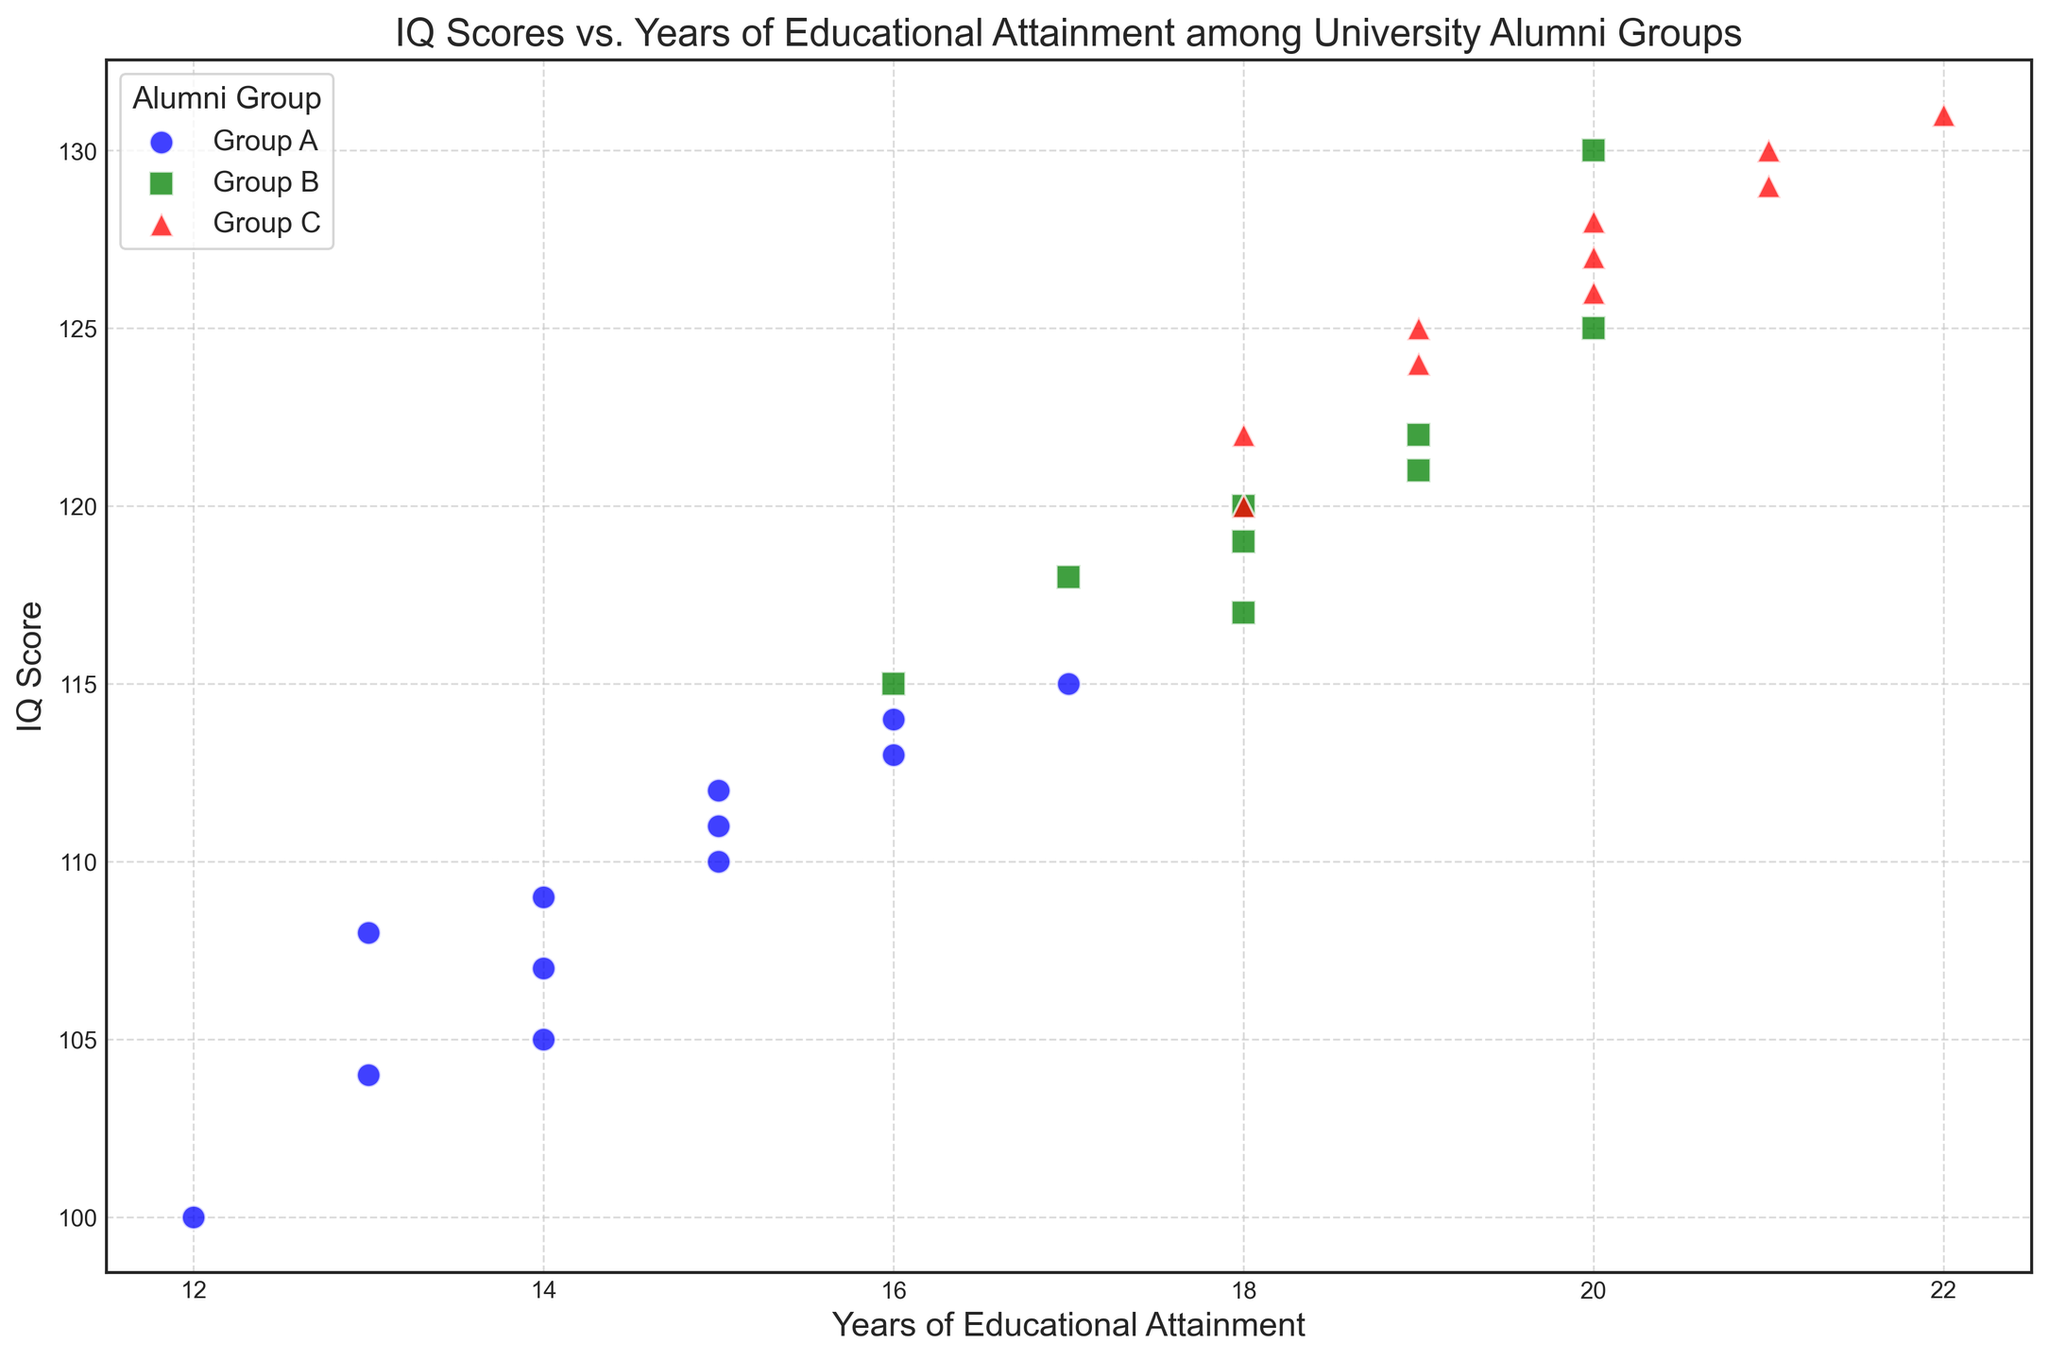What is the average IQ score for Group A alumni? To find the average IQ score for Group A alumni, sum the IQ scores for Group A and divide by the number of data points. The IQ scores for Group A are 110, 105, 100, 108, 112, 109, 104, 107, 111, 113, 114, and 115. The sum is 1208, and there are 12 data points. So, the average is 1208 / 12.
Answer: 100.67 Which alumni group has the highest IQ score in the dataset? For this question, we need to identify the alumni group associated with the highest IQ score in the scatter plot. The highest IQ score is 131, and it belongs to Group C.
Answer: Group C What is the range of years of educational attainment for Group B? To calculate the range, subtract the minimum years of educational attainment from the maximum years for Group B. Group B has educational years of 16, 20, 17, 18, 19, 18, 19, 19, and 20. The range is 20 - 16.
Answer: 4 Do alumni with higher years of educational attainment generally have higher IQ scores across all groups? To answer this, observe the scatter plot trendlines for each group. Alumni with higher educational attainment (closer to 20+ years) generally show higher IQ scores (closer to 120-130) for all groups A, B, and C. This indicates a positive correlation.
Answer: Yes Which group shows more variability in IQ scores: Group A or Group C? To determine variability, examine the distribution/spread of IQ scores for both groups on the scatter plot. Group A's IQ scores range from 100 to 115 (a range of 15), while Group C's IQ scores range from 120 to 131 (a range of 11). Hence, Group A shows more variability.
Answer: Group A How many more years of educational attainment does the alumni with the highest IQ in Group C have compared to the alumni with the lowest IQ in Group A? The highest IQ in Group C is 131 (22 years), and the lowest IQ in Group A is 100 (12 years). Subtract the years of educational attainment: 22 - 12.
Answer: 10 years What color represents Group B on the scatter plot? For the visual identification, refer to the color legend in the plot. Group B is represented by green.
Answer: Green Which group has the most consistent years of educational attainment, and what is the number of unique years observed? By comparing the years for each group, Group A has 12, 13, 14, 15, 16, 17 (6 unique years), Group B has 16, 17, 18, 19, 20 (5 unique years), and Group C has 18, 19, 20, 21, 22 (5 unique years). Group B and C have the same number.
Answer: Group B and Group C have 5 unique years Which group has at least one alumni with 15 years of educational attainment, and what are their IQ scores? From the scatter plot, identify which groups have data points for 15 years of educational attainment and note their IQ scores. Group A has alumni at 15 years with IQ scores of 110, 112, and 111; no other group has 15 years listed.
Answer: Group A with IQ scores 110, 112, and 111 